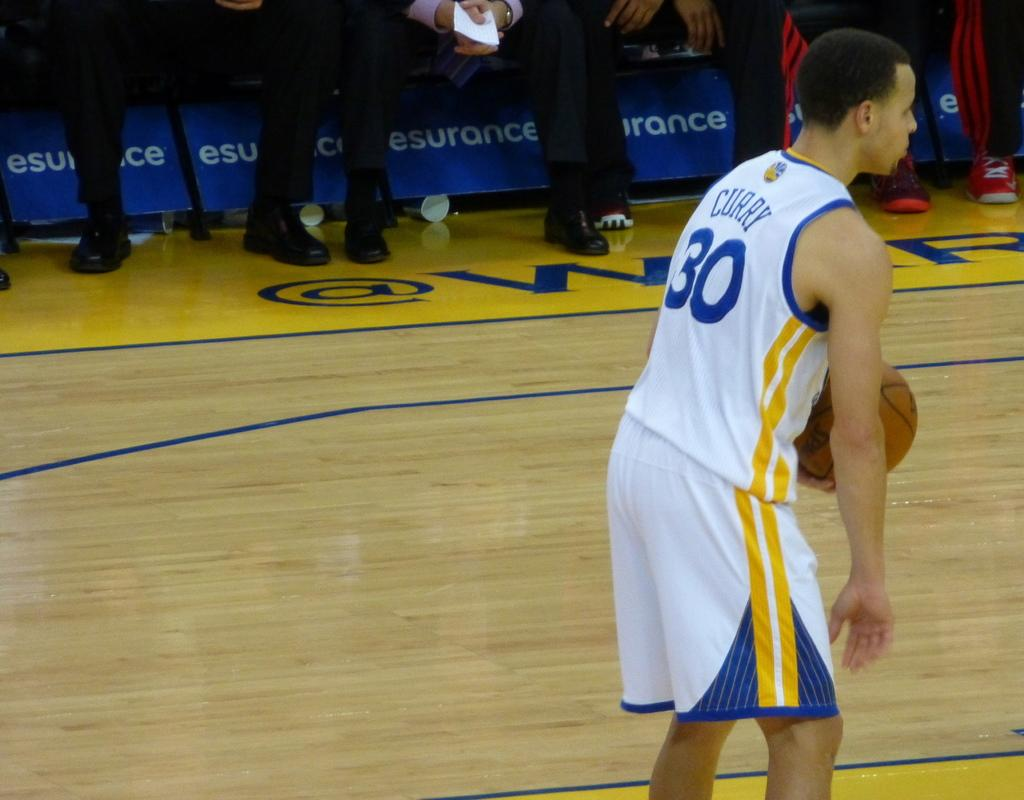<image>
Relay a brief, clear account of the picture shown. a player wit the number 30 on the back of the jersey 